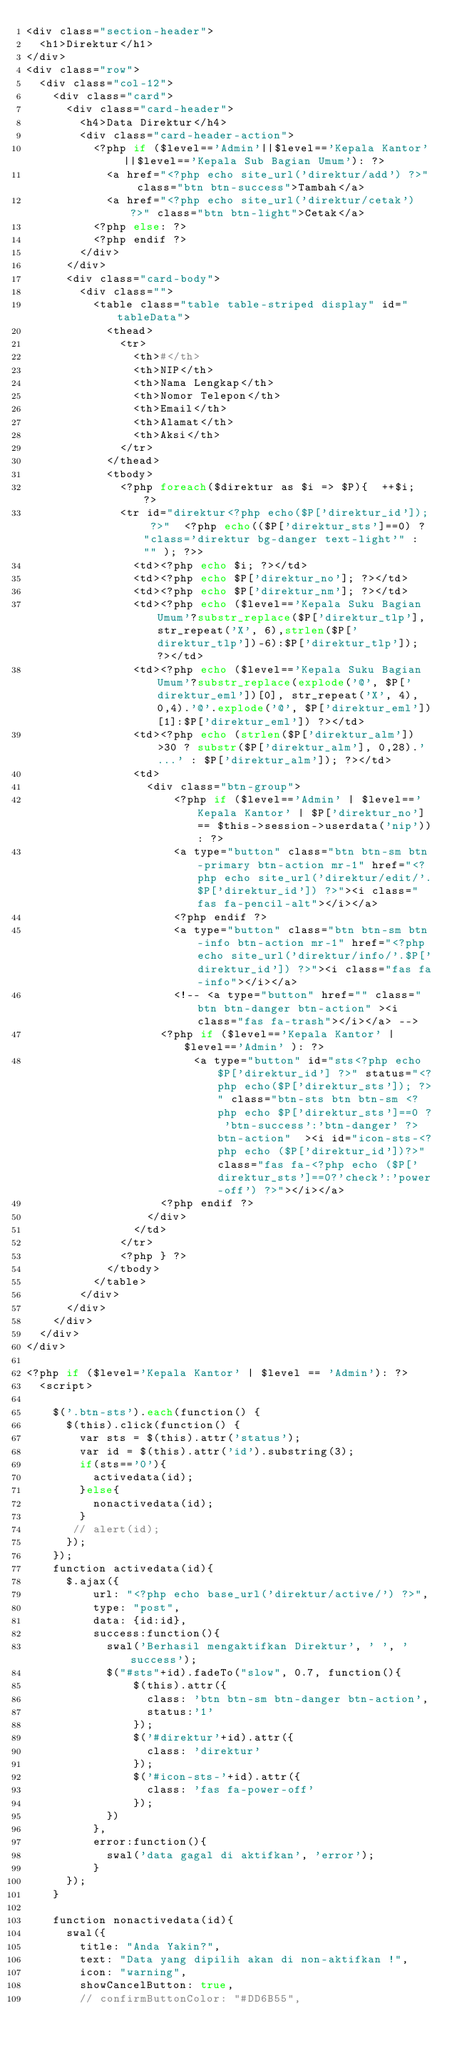<code> <loc_0><loc_0><loc_500><loc_500><_PHP_><div class="section-header">
  <h1>Direktur</h1>
</div>
<div class="row">
  <div class="col-12">
    <div class="card">
      <div class="card-header">
        <h4>Data Direktur</h4>
        <div class="card-header-action">
          <?php if ($level=='Admin'||$level=='Kepala Kantor' ||$level=='Kepala Sub Bagian Umum'): ?>
            <a href="<?php echo site_url('direktur/add') ?>" class="btn btn-success">Tambah</a>
            <a href="<?php echo site_url('direktur/cetak') ?>" class="btn btn-light">Cetak</a>
          <?php else: ?>
          <?php endif ?>
        </div>
      </div>
      <div class="card-body">
        <div class="">
          <table class="table table-striped display" id="tableData">
            <thead>
              <tr>
                <th>#</th>
                <th>NIP</th>
                <th>Nama Lengkap</th>
                <th>Nomor Telepon</th>
                <th>Email</th>
                <th>Alamat</th>
                <th>Aksi</th>
              </tr>
            </thead>
            <tbody>     
              <?php foreach($direktur as $i => $P){  ++$i; ?>
              <tr id="direktur<?php echo($P['direktur_id']); ?>"  <?php echo(($P['direktur_sts']==0) ? "class='direktur bg-danger text-light'" :  "" ); ?>>
                <td><?php echo $i; ?></td>
                <td><?php echo $P['direktur_no']; ?></td>
                <td><?php echo $P['direktur_nm']; ?></td>
                <td><?php echo ($level=='Kepala Suku Bagian Umum'?substr_replace($P['direktur_tlp'], str_repeat('X', 6),strlen($P['direktur_tlp'])-6):$P['direktur_tlp']); ?></td>
                <td><?php echo ($level=='Kepala Suku Bagian Umum'?substr_replace(explode('@', $P['direktur_eml'])[0], str_repeat('X', 4), 0,4).'@'.explode('@', $P['direktur_eml'])[1]:$P['direktur_eml']) ?></td>
                <td><?php echo (strlen($P['direktur_alm'])>30 ? substr($P['direktur_alm'], 0,28).'...' : $P['direktur_alm']); ?></td>
                <td>
                  <div class="btn-group">
                      <?php if ($level=='Admin' | $level=='Kepala Kantor' | $P['direktur_no'] == $this->session->userdata('nip')): ?>
                      <a type="button" class="btn btn-sm btn-primary btn-action mr-1" href="<?php echo site_url('direktur/edit/'.$P['direktur_id']) ?>"><i class="fas fa-pencil-alt"></i></a>
                      <?php endif ?>
                      <a type="button" class="btn btn-sm btn-info btn-action mr-1" href="<?php echo site_url('direktur/info/'.$P['direktur_id']) ?>"><i class="fas fa-info"></i></a>
                      <!-- <a type="button" href="" class="btn btn-danger btn-action" ><i class="fas fa-trash"></i></a> -->                
                    <?php if ($level=='Kepala Kantor' | $level=='Admin' ): ?>
                         <a type="button" id="sts<?php echo $P['direktur_id'] ?>" status="<?php echo($P['direktur_sts']); ?>" class="btn-sts btn btn-sm <?php echo $P['direktur_sts']==0 ? 'btn-success':'btn-danger' ?> btn-action"  ><i id="icon-sts-<?php echo ($P['direktur_id'])?>" class="fas fa-<?php echo ($P['direktur_sts']==0?'check':'power-off') ?>"></i></a>
                    <?php endif ?>
                  </div>
                </td>
              </tr>
              <?php } ?>
            </tbody>
          </table>
        </div>
      </div>
    </div>
  </div>
</div>

<?php if ($level='Kepala Kantor' | $level == 'Admin'): ?>
  <script>

    $('.btn-sts').each(function() {
      $(this).click(function() {
        var sts = $(this).attr('status');
        var id = $(this).attr('id').substring(3);
        if(sts=='0'){
          activedata(id);
        }else{
          nonactivedata(id);
        }
       // alert(id);
      });
    });
    function activedata(id){
      $.ajax({
          url: "<?php echo base_url('direktur/active/') ?>",
          type: "post",
          data: {id:id},
          success:function(){
            swal('Berhasil mengaktifkan Direktur', ' ', 'success');
            $("#sts"+id).fadeTo("slow", 0.7, function(){
                $(this).attr({
                  class: 'btn btn-sm btn-danger btn-action',
                  status:'1'
                });
                $('#direktur'+id).attr({
                  class: 'direktur'
                });
                $('#icon-sts-'+id).attr({
                  class: 'fas fa-power-off'
                });
            })
          },
          error:function(){
            swal('data gagal di aktifkan', 'error');
          }
      });
    }

    function nonactivedata(id){
      swal({
        title: "Anda Yakin?",
        text: "Data yang dipilih akan di non-aktifkan !",
        icon: "warning",
        showCancelButton: true,
        // confirmButtonColor: "#DD6B55",</code> 